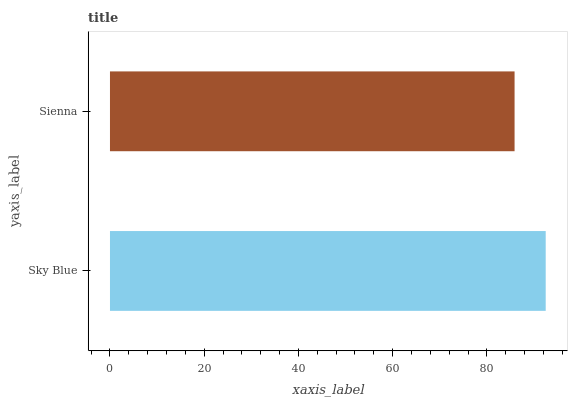Is Sienna the minimum?
Answer yes or no. Yes. Is Sky Blue the maximum?
Answer yes or no. Yes. Is Sienna the maximum?
Answer yes or no. No. Is Sky Blue greater than Sienna?
Answer yes or no. Yes. Is Sienna less than Sky Blue?
Answer yes or no. Yes. Is Sienna greater than Sky Blue?
Answer yes or no. No. Is Sky Blue less than Sienna?
Answer yes or no. No. Is Sky Blue the high median?
Answer yes or no. Yes. Is Sienna the low median?
Answer yes or no. Yes. Is Sienna the high median?
Answer yes or no. No. Is Sky Blue the low median?
Answer yes or no. No. 